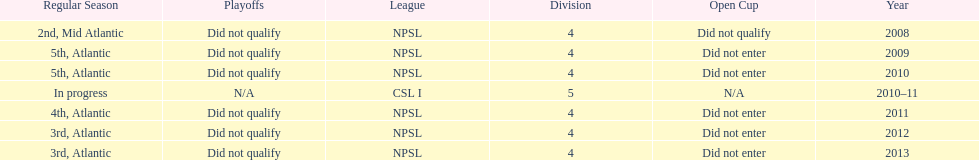Using the data, what should be the next year they will play? 2014. 